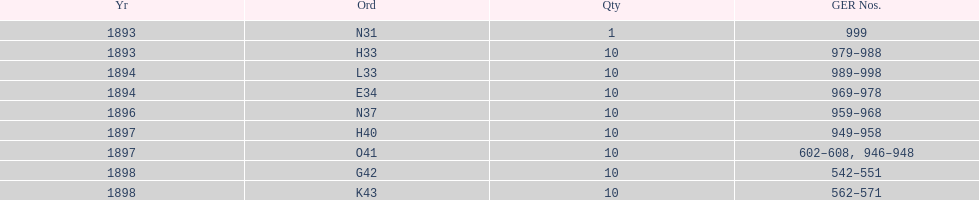How many years have had g.e.r. numbers below 900? 2. 